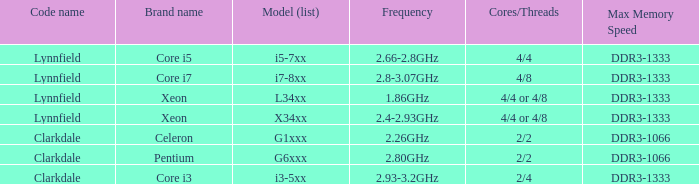What brand is model G6xxx? Pentium. 